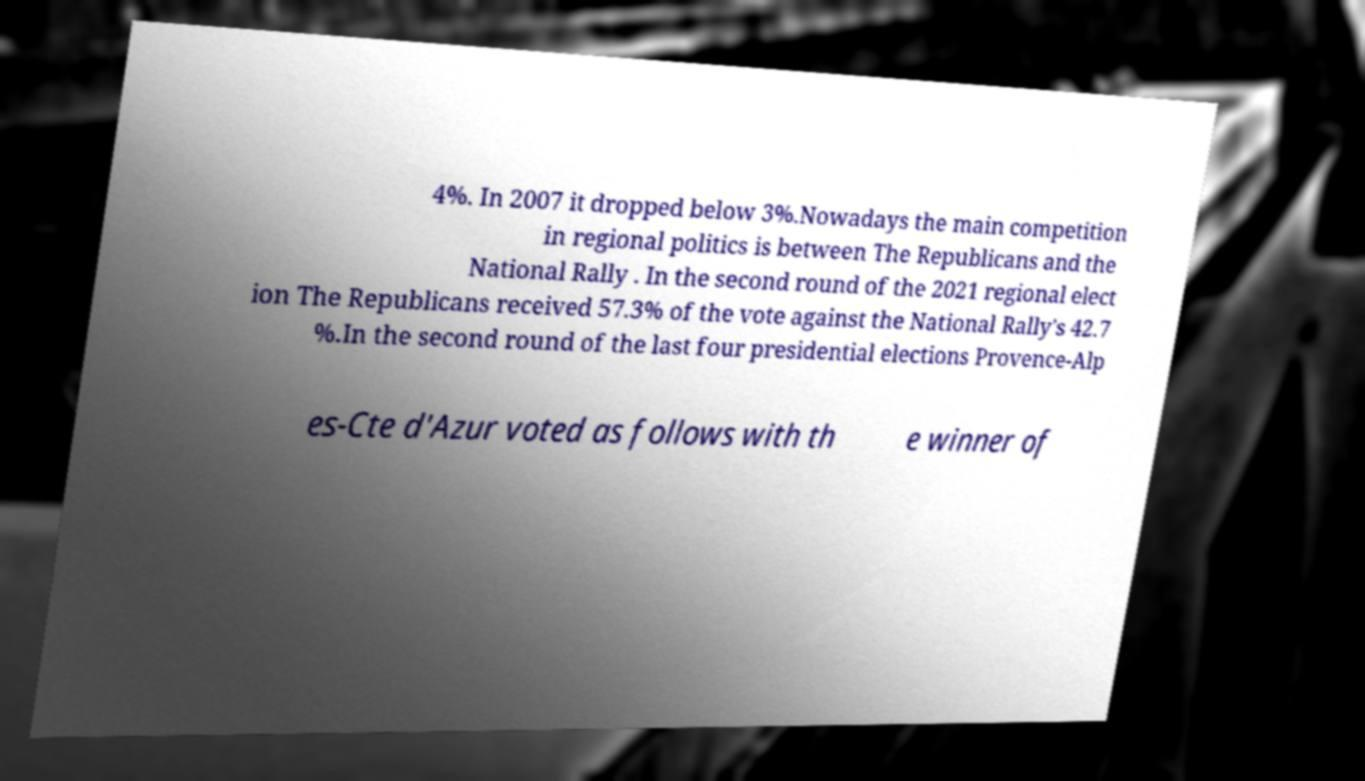Please identify and transcribe the text found in this image. 4%. In 2007 it dropped below 3%.Nowadays the main competition in regional politics is between The Republicans and the National Rally . In the second round of the 2021 regional elect ion The Republicans received 57.3% of the vote against the National Rally's 42.7 %.In the second round of the last four presidential elections Provence-Alp es-Cte d'Azur voted as follows with th e winner of 